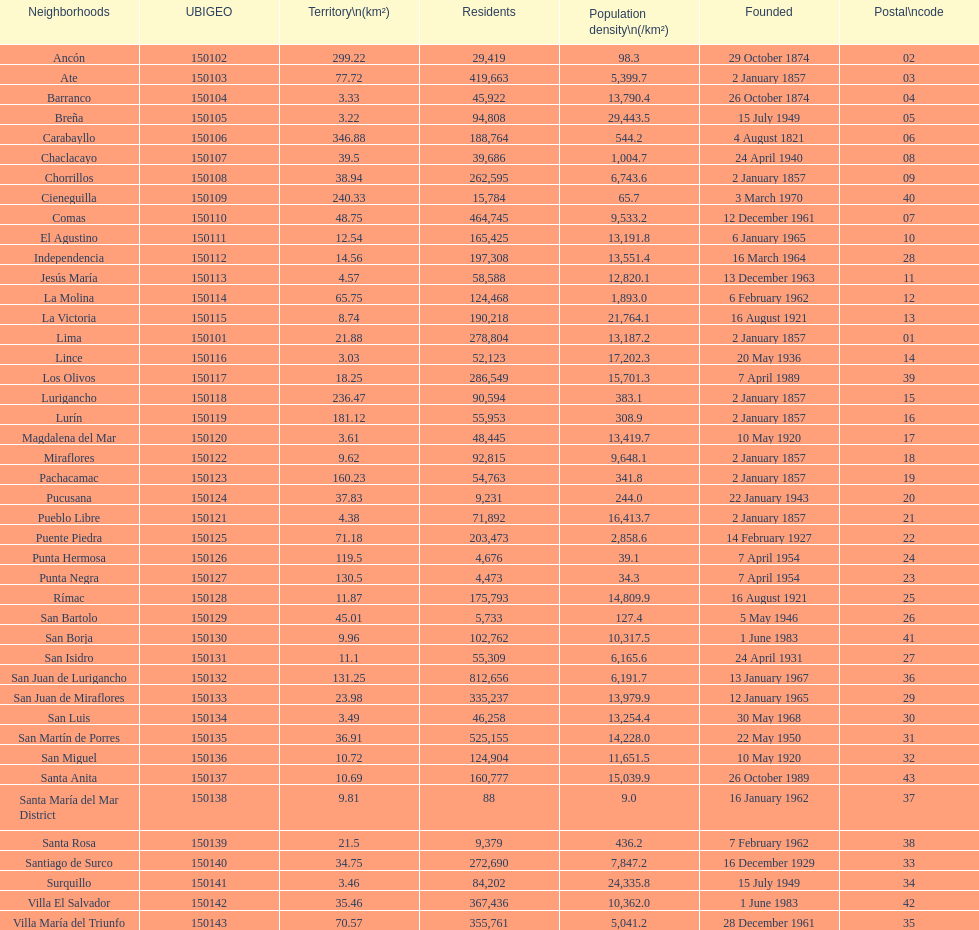What was the last district created? Santa Anita. 